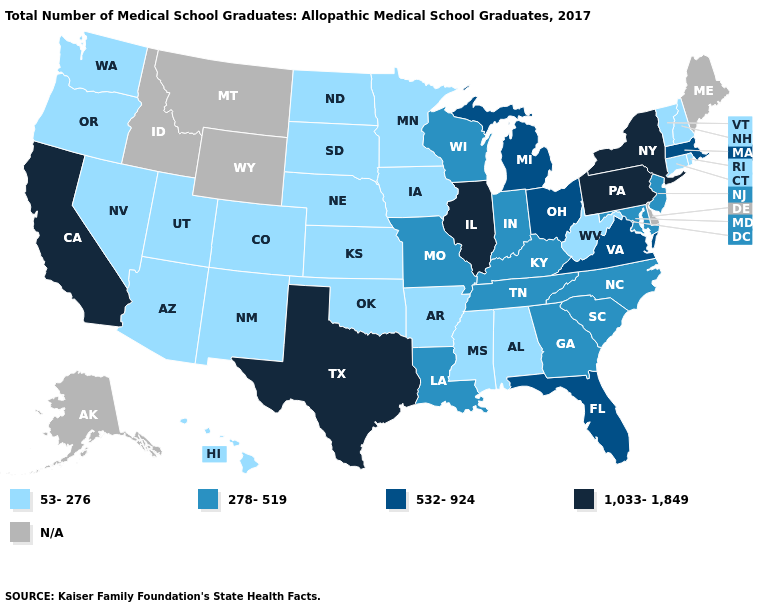Which states have the highest value in the USA?
Answer briefly. California, Illinois, New York, Pennsylvania, Texas. Among the states that border Virginia , which have the highest value?
Give a very brief answer. Kentucky, Maryland, North Carolina, Tennessee. What is the highest value in states that border Colorado?
Be succinct. 53-276. Name the states that have a value in the range 532-924?
Quick response, please. Florida, Massachusetts, Michigan, Ohio, Virginia. Name the states that have a value in the range 532-924?
Short answer required. Florida, Massachusetts, Michigan, Ohio, Virginia. What is the lowest value in states that border Arkansas?
Short answer required. 53-276. Does Pennsylvania have the highest value in the Northeast?
Keep it brief. Yes. Is the legend a continuous bar?
Write a very short answer. No. Among the states that border Alabama , does Georgia have the lowest value?
Answer briefly. No. What is the highest value in states that border Washington?
Be succinct. 53-276. Name the states that have a value in the range N/A?
Write a very short answer. Alaska, Delaware, Idaho, Maine, Montana, Wyoming. What is the lowest value in the MidWest?
Answer briefly. 53-276. Does West Virginia have the lowest value in the South?
Concise answer only. Yes. 